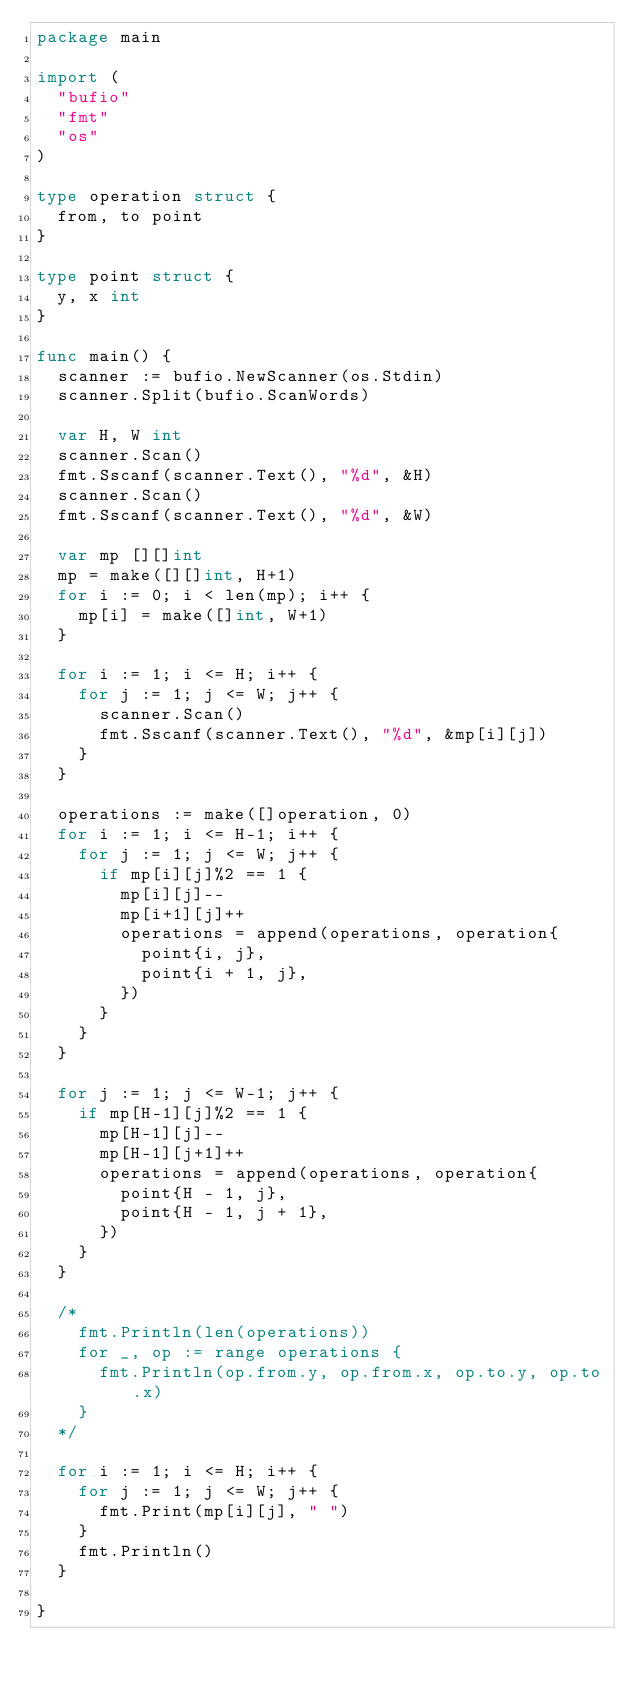<code> <loc_0><loc_0><loc_500><loc_500><_Go_>package main

import (
	"bufio"
	"fmt"
	"os"
)

type operation struct {
	from, to point
}

type point struct {
	y, x int
}

func main() {
	scanner := bufio.NewScanner(os.Stdin)
	scanner.Split(bufio.ScanWords)

	var H, W int
	scanner.Scan()
	fmt.Sscanf(scanner.Text(), "%d", &H)
	scanner.Scan()
	fmt.Sscanf(scanner.Text(), "%d", &W)

	var mp [][]int
	mp = make([][]int, H+1)
	for i := 0; i < len(mp); i++ {
		mp[i] = make([]int, W+1)
	}

	for i := 1; i <= H; i++ {
		for j := 1; j <= W; j++ {
			scanner.Scan()
			fmt.Sscanf(scanner.Text(), "%d", &mp[i][j])
		}
	}

	operations := make([]operation, 0)
	for i := 1; i <= H-1; i++ {
		for j := 1; j <= W; j++ {
			if mp[i][j]%2 == 1 {
				mp[i][j]--
				mp[i+1][j]++
				operations = append(operations, operation{
					point{i, j},
					point{i + 1, j},
				})
			}
		}
	}

	for j := 1; j <= W-1; j++ {
		if mp[H-1][j]%2 == 1 {
			mp[H-1][j]--
			mp[H-1][j+1]++
			operations = append(operations, operation{
				point{H - 1, j},
				point{H - 1, j + 1},
			})
		}
	}

	/*
		fmt.Println(len(operations))
		for _, op := range operations {
			fmt.Println(op.from.y, op.from.x, op.to.y, op.to.x)
		}
	*/

	for i := 1; i <= H; i++ {
		for j := 1; j <= W; j++ {
			fmt.Print(mp[i][j], " ")
		}
		fmt.Println()
	}

}
</code> 